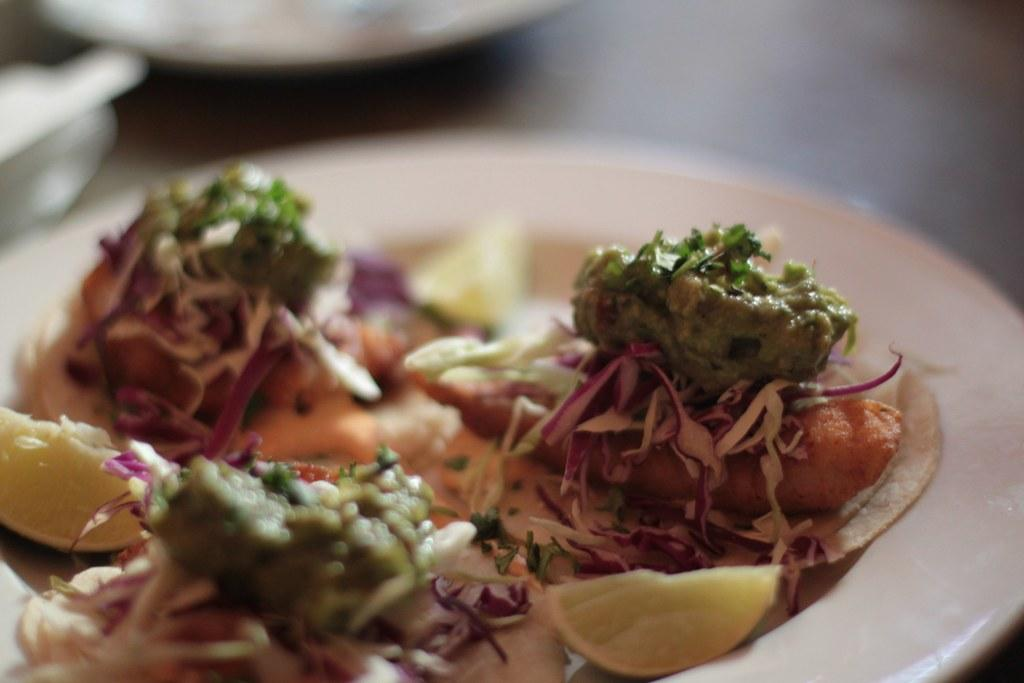What type of furniture is present in the image? There is a table in the image. What is placed on the table? There are plates on the table. What else can be seen on the table besides plates? There is food placed on the table. How many sticks are visible on the table in the image? There are no sticks visible on the table in the image. Is there a snake present on the table in the image? No, there is no snake present on the table in the image. 